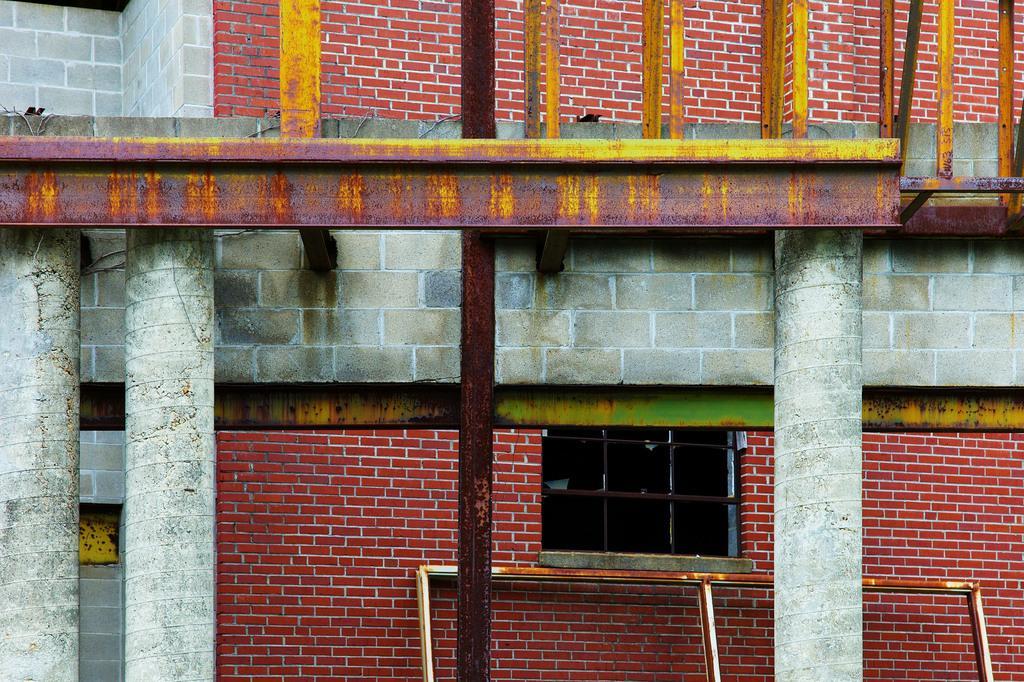How would you summarize this image in a sentence or two? In this picture there is a building. On the left there are two pillows near to the brick wall. At the bottom there is a steel frame which is kept near to the window and pillar. 